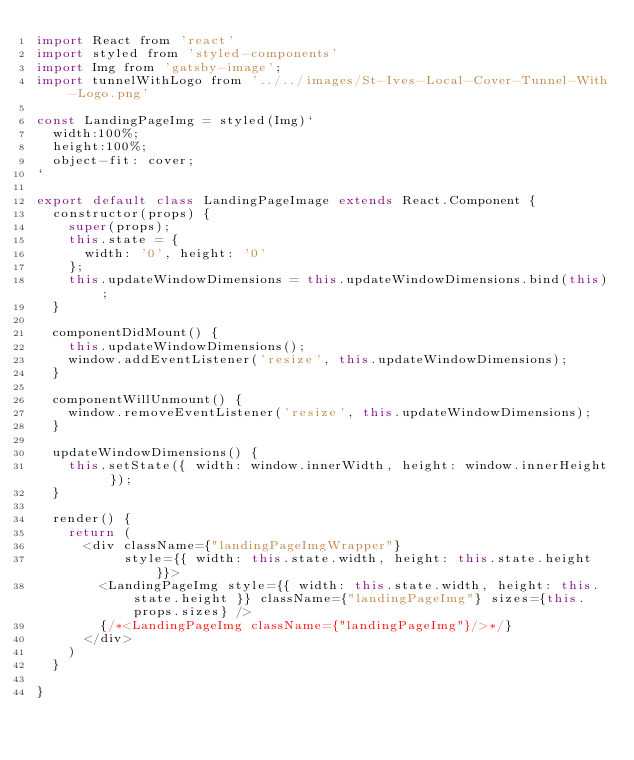Convert code to text. <code><loc_0><loc_0><loc_500><loc_500><_JavaScript_>import React from 'react'
import styled from 'styled-components'
import Img from 'gatsby-image';
import tunnelWithLogo from '../../images/St-Ives-Local-Cover-Tunnel-With-Logo.png'

const LandingPageImg = styled(Img)`
  width:100%;
  height:100%;
  object-fit: cover;
`

export default class LandingPageImage extends React.Component {
  constructor(props) {
    super(props);
    this.state = {
      width: '0', height: '0'
    };
    this.updateWindowDimensions = this.updateWindowDimensions.bind(this);
  }

  componentDidMount() {
    this.updateWindowDimensions();
    window.addEventListener('resize', this.updateWindowDimensions);
  }

  componentWillUnmount() {
    window.removeEventListener('resize', this.updateWindowDimensions);
  }

  updateWindowDimensions() {
    this.setState({ width: window.innerWidth, height: window.innerHeight });
  }

  render() {
    return (
      <div className={"landingPageImgWrapper"}
           style={{ width: this.state.width, height: this.state.height }}>
        <LandingPageImg style={{ width: this.state.width, height: this.state.height }} className={"landingPageImg"} sizes={this.props.sizes} />
        {/*<LandingPageImg className={"landingPageImg"}/>*/}
      </div>
    )
  }

}

</code> 